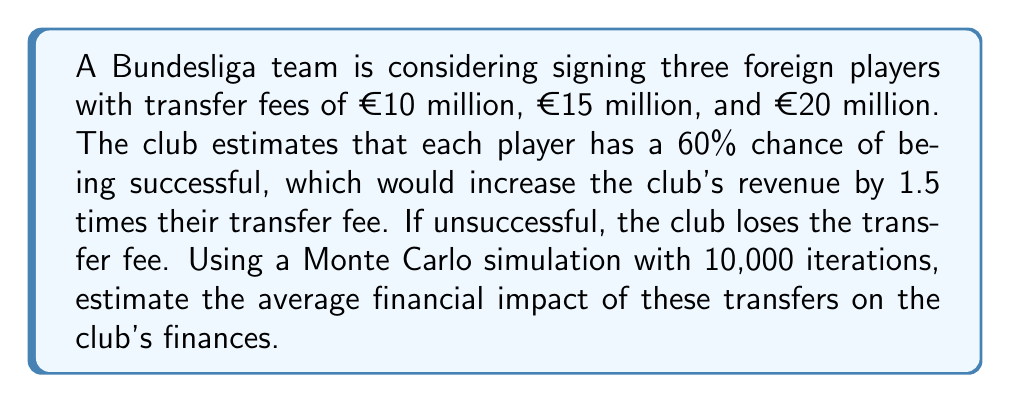Solve this math problem. 1. Set up the simulation:
   - Define success probability: $p = 0.6$
   - Define transfer fees: $f_1 = 10$, $f_2 = 15$, $f_3 = 20$ (in millions of euros)
   - Set number of iterations: $n = 10000$

2. For each iteration:
   a. Generate three random numbers $r_1$, $r_2$, $r_3$ between 0 and 1
   b. For each player $i$:
      - If $r_i \leq p$, the player is successful: gain = $1.5 \times f_i$
      - If $r_i > p$, the player is unsuccessful: gain = $-f_i$
   c. Sum the gains for all three players

3. Calculate the average financial impact:
   $\text{Average Impact} = \frac{\sum_{i=1}^n \text{Total Gain}_i}{n}$

4. Implement the simulation in code (pseudo-code):

```
total_sum = 0
for i in range(10000):
    gain = 0
    for fee in [10, 15, 20]:
        if random() <= 0.6:
            gain += 1.5 * fee
        else:
            gain -= fee
    total_sum += gain
average_impact = total_sum / 10000
```

5. Run the simulation and calculate the result:
   The average financial impact after 10,000 iterations is approximately €6.75 million.

This result suggests that, on average, the club can expect a positive financial impact from these transfers, despite the risk of unsuccessful players.
Answer: €6.75 million 